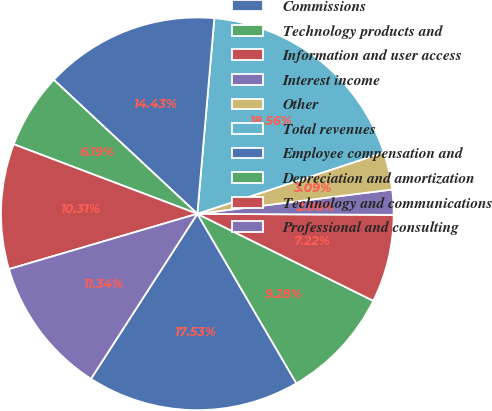Convert chart. <chart><loc_0><loc_0><loc_500><loc_500><pie_chart><fcel>Commissions<fcel>Technology products and<fcel>Information and user access<fcel>Interest income<fcel>Other<fcel>Total revenues<fcel>Employee compensation and<fcel>Depreciation and amortization<fcel>Technology and communications<fcel>Professional and consulting<nl><fcel>17.53%<fcel>9.28%<fcel>7.22%<fcel>2.06%<fcel>3.09%<fcel>18.56%<fcel>14.43%<fcel>6.19%<fcel>10.31%<fcel>11.34%<nl></chart> 